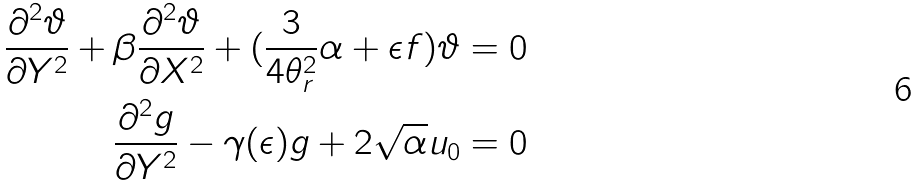Convert formula to latex. <formula><loc_0><loc_0><loc_500><loc_500>\frac { \partial ^ { 2 } \vartheta } { \partial Y ^ { 2 } } + \beta \frac { \partial ^ { 2 } \vartheta } { \partial X ^ { 2 } } + ( \frac { 3 } { 4 \theta _ { r } ^ { 2 } } \alpha + \epsilon f ) \vartheta & = 0 \\ \frac { \partial ^ { 2 } g } { \partial Y ^ { 2 } } - \gamma ( \epsilon ) g + 2 \sqrt { \alpha } u _ { 0 } & = 0</formula> 